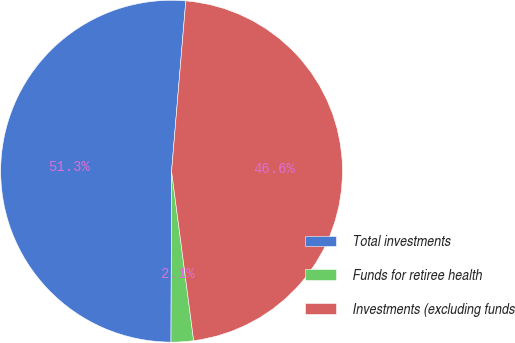<chart> <loc_0><loc_0><loc_500><loc_500><pie_chart><fcel>Total investments<fcel>Funds for retiree health<fcel>Investments (excluding funds<nl><fcel>51.27%<fcel>2.12%<fcel>46.61%<nl></chart> 